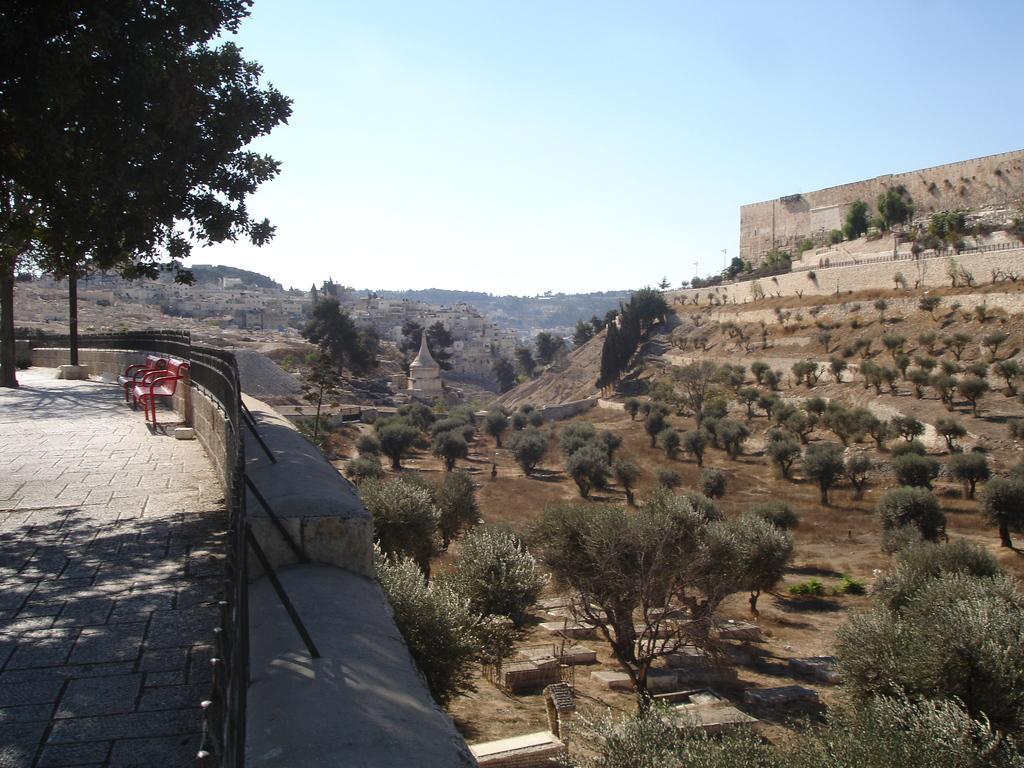In one or two sentences, can you explain what this image depicts? In this image, we can see the floor and a wall on the left side, on the right side there are some plants and trees, at the top we can see the sky. 